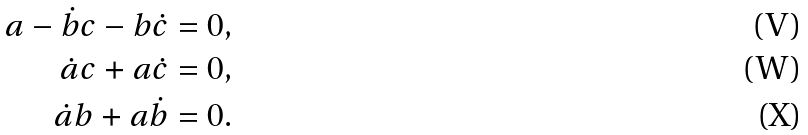Convert formula to latex. <formula><loc_0><loc_0><loc_500><loc_500>a - \dot { b } c - b \dot { c } = 0 , \\ \dot { a } c + a \dot { c } = 0 , \\ \dot { a } b + a \dot { b } = 0 .</formula> 